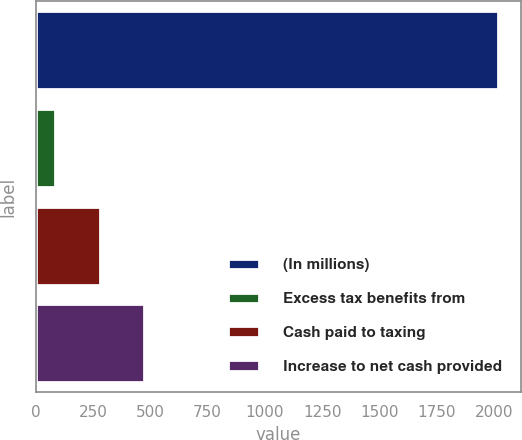<chart> <loc_0><loc_0><loc_500><loc_500><bar_chart><fcel>(In millions)<fcel>Excess tax benefits from<fcel>Cash paid to taxing<fcel>Increase to net cash provided<nl><fcel>2016<fcel>86<fcel>279<fcel>472<nl></chart> 